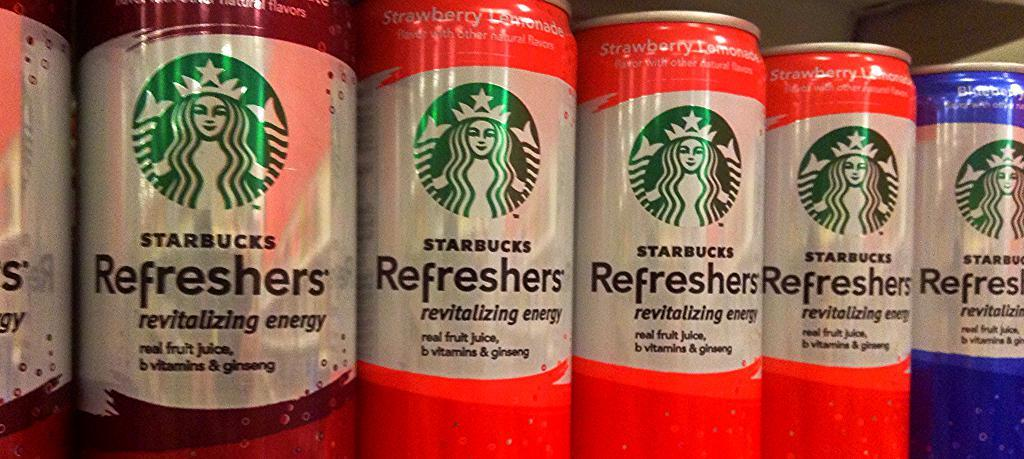What type of objects are arranged in a row in the image? There are beverage tins arranged in a row in the image. How are the beverage tins positioned in relation to each other? The beverage tins are arranged in a row, meaning they are placed one after the other in a straight line. What color is the vest worn by the robin in the image? There is no robin or vest present in the image; it features an arrangement of beverage tins. 